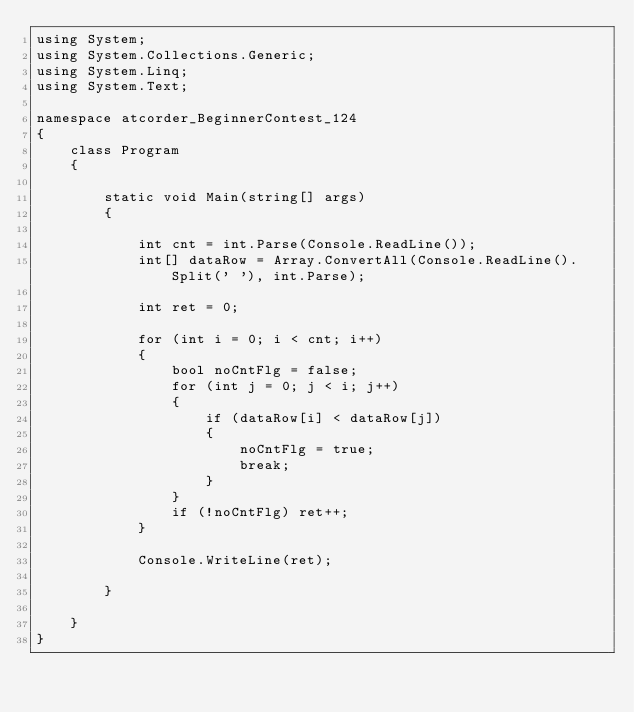Convert code to text. <code><loc_0><loc_0><loc_500><loc_500><_C#_>using System;
using System.Collections.Generic;
using System.Linq;
using System.Text;

namespace atcorder_BeginnerContest_124
{
    class Program
    {

        static void Main(string[] args)
        {

            int cnt = int.Parse(Console.ReadLine());
            int[] dataRow = Array.ConvertAll(Console.ReadLine().Split(' '), int.Parse);

            int ret = 0;

            for (int i = 0; i < cnt; i++)
            {
                bool noCntFlg = false;
                for (int j = 0; j < i; j++)
                {
                    if (dataRow[i] < dataRow[j])
                    {
                        noCntFlg = true;
                        break;
                    }
                }
                if (!noCntFlg) ret++;
            }

            Console.WriteLine(ret);

        }

    }
}

</code> 